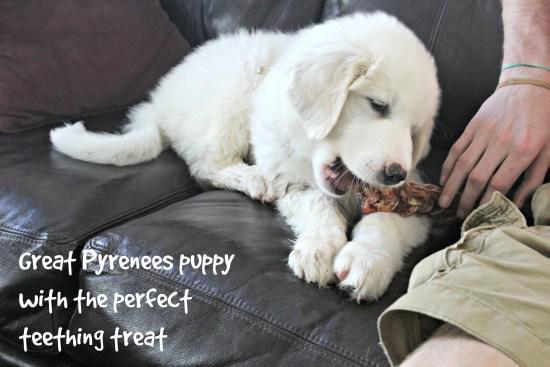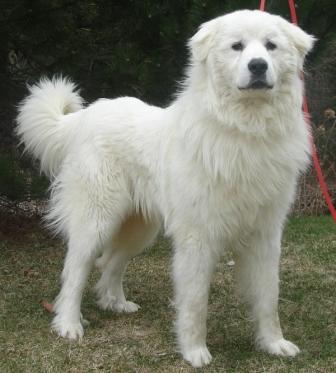The first image is the image on the left, the second image is the image on the right. Considering the images on both sides, is "There is one puppy and one adult dog" valid? Answer yes or no. Yes. The first image is the image on the left, the second image is the image on the right. For the images displayed, is the sentence "The left image contains one non-standing white puppy, while the right image contains one standing white adult dog." factually correct? Answer yes or no. Yes. 